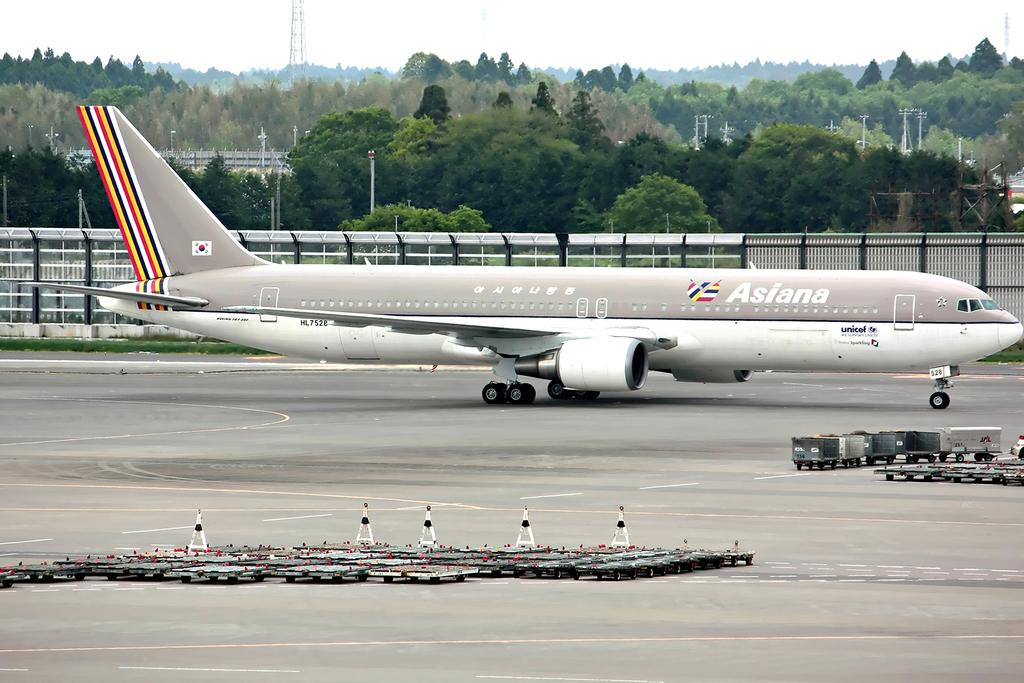What is the main subject of the image? The main subject of the image is an airplane. What other objects can be seen in the image? There are traffic cones, trucks, objects on the runway, fencing, trees, poles, and towers in the image. What is visible in the sky in the image? The sky is visible in the image. What is the rate of the fictional character's attempt to fly in the image? There is no fictional character present in the image, and therefore no attempt to fly can be observed. 